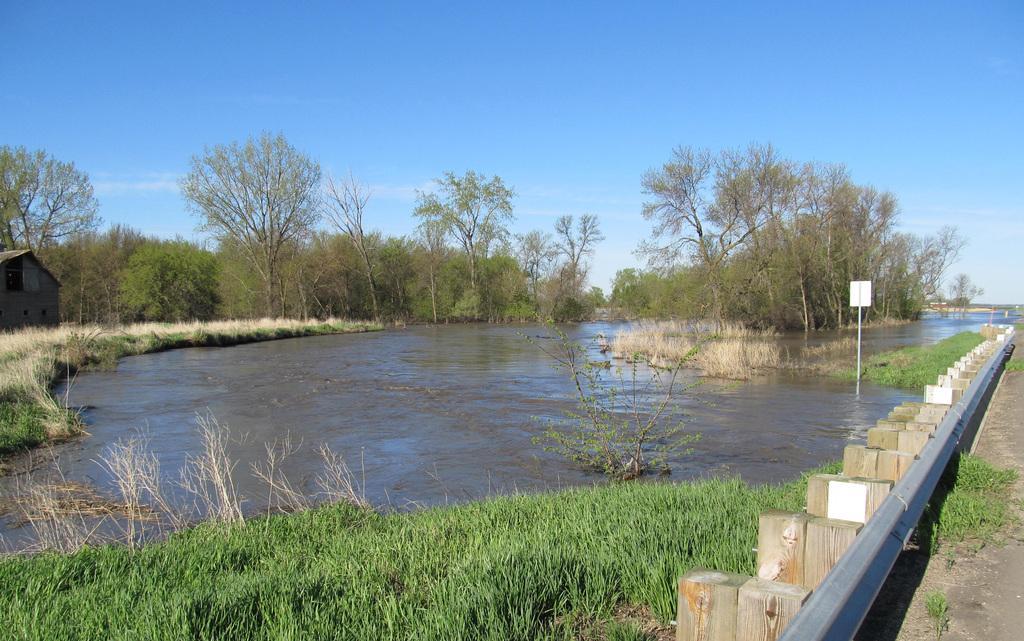How would you summarize this image in a sentence or two? In the background we can see the sky. In this picture we can see the trees, water, plants, grass, board, pole, wooden objects and railing. On the left side of the picture we can see a house. 